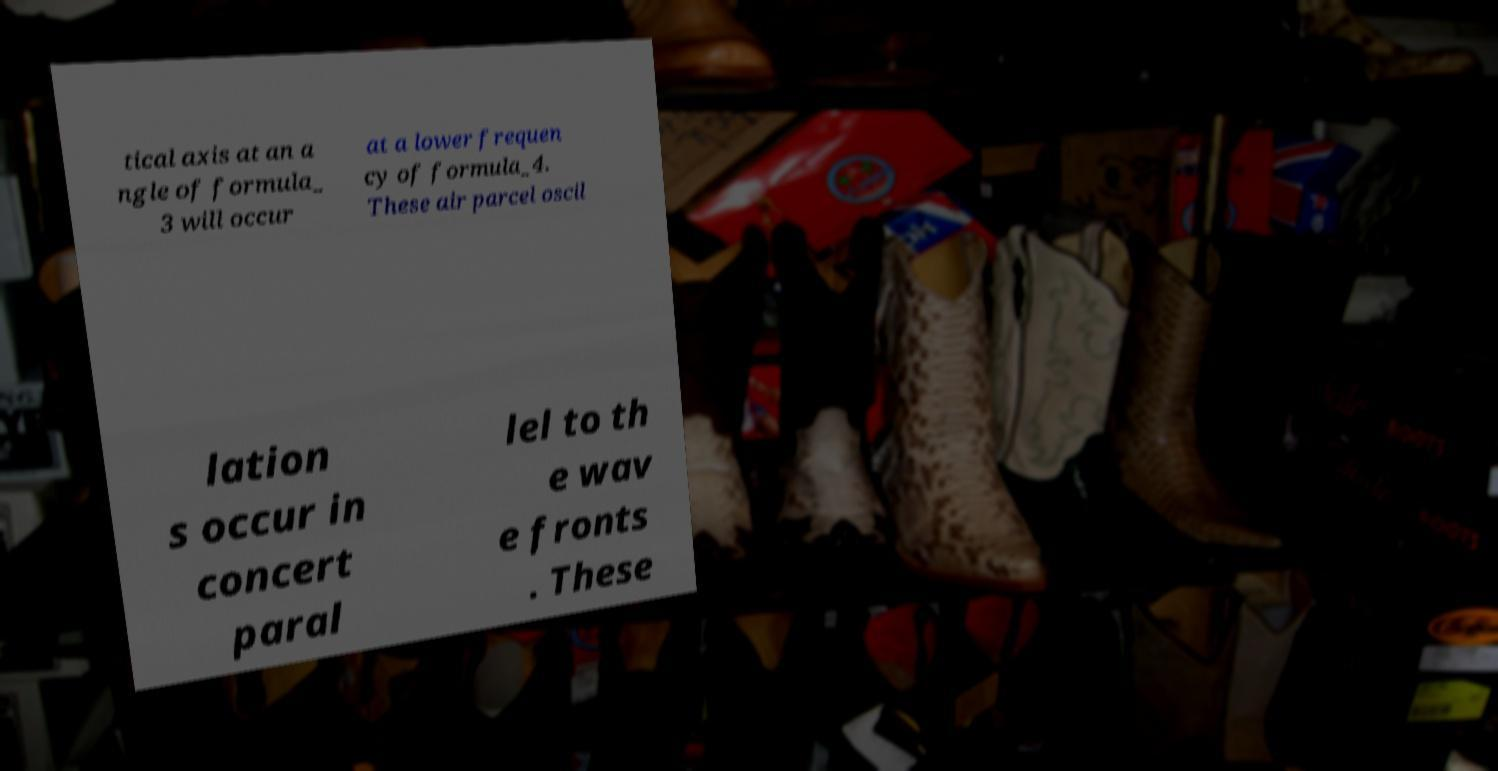Could you assist in decoding the text presented in this image and type it out clearly? tical axis at an a ngle of formula_ 3 will occur at a lower frequen cy of formula_4. These air parcel oscil lation s occur in concert paral lel to th e wav e fronts . These 